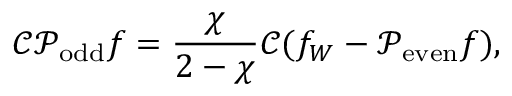<formula> <loc_0><loc_0><loc_500><loc_500>\mathcal { C } \mathcal { P } _ { o d d } f = \frac { \chi } { 2 - \chi } \mathcal { C } ( f _ { W } - \mathcal { P } _ { e v e n } f ) ,</formula> 